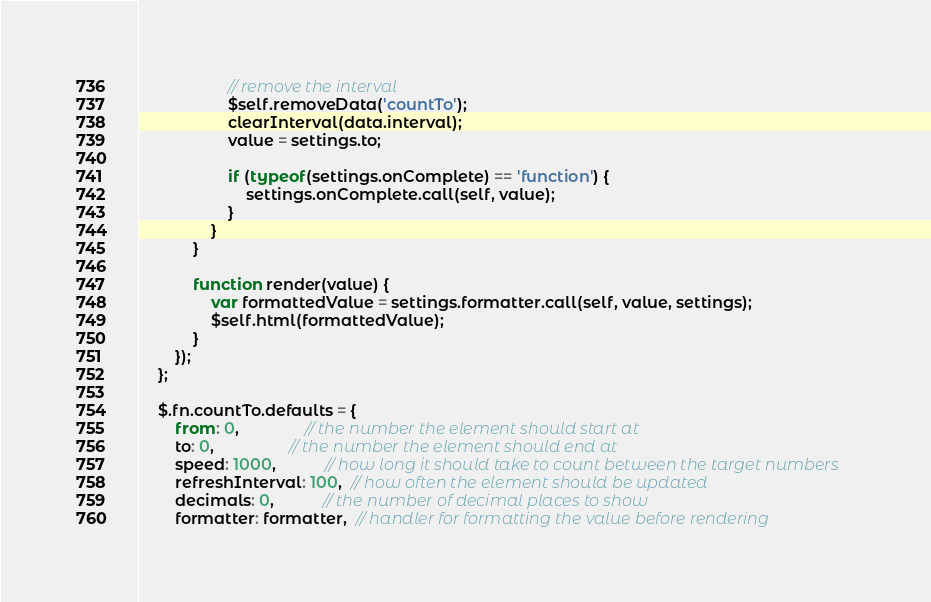<code> <loc_0><loc_0><loc_500><loc_500><_JavaScript_>					// remove the interval
					$self.removeData('countTo');
					clearInterval(data.interval);
					value = settings.to;
					
					if (typeof(settings.onComplete) == 'function') {
						settings.onComplete.call(self, value);
					}
				}
			}
			
			function render(value) {
				var formattedValue = settings.formatter.call(self, value, settings);
				$self.html(formattedValue);
			}
		});
	};
	
	$.fn.countTo.defaults = {
		from: 0,               // the number the element should start at
		to: 0,                 // the number the element should end at
		speed: 1000,           // how long it should take to count between the target numbers
		refreshInterval: 100,  // how often the element should be updated
		decimals: 0,           // the number of decimal places to show
		formatter: formatter,  // handler for formatting the value before rendering</code> 